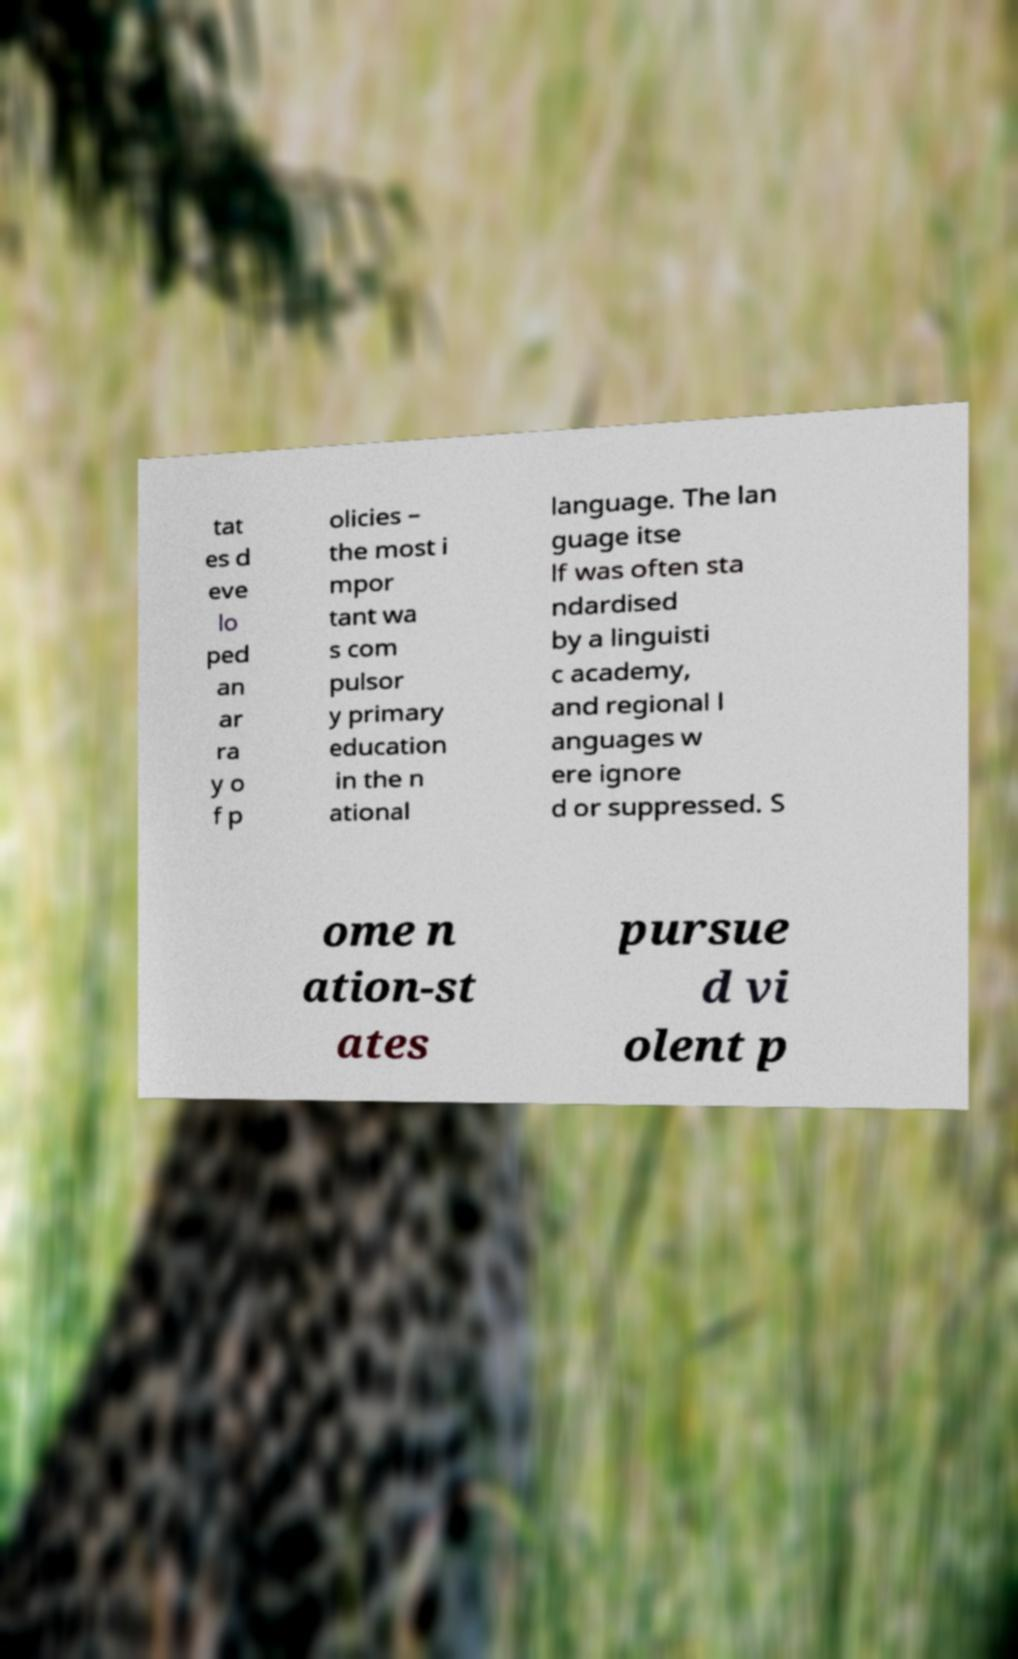For documentation purposes, I need the text within this image transcribed. Could you provide that? tat es d eve lo ped an ar ra y o f p olicies – the most i mpor tant wa s com pulsor y primary education in the n ational language. The lan guage itse lf was often sta ndardised by a linguisti c academy, and regional l anguages w ere ignore d or suppressed. S ome n ation-st ates pursue d vi olent p 